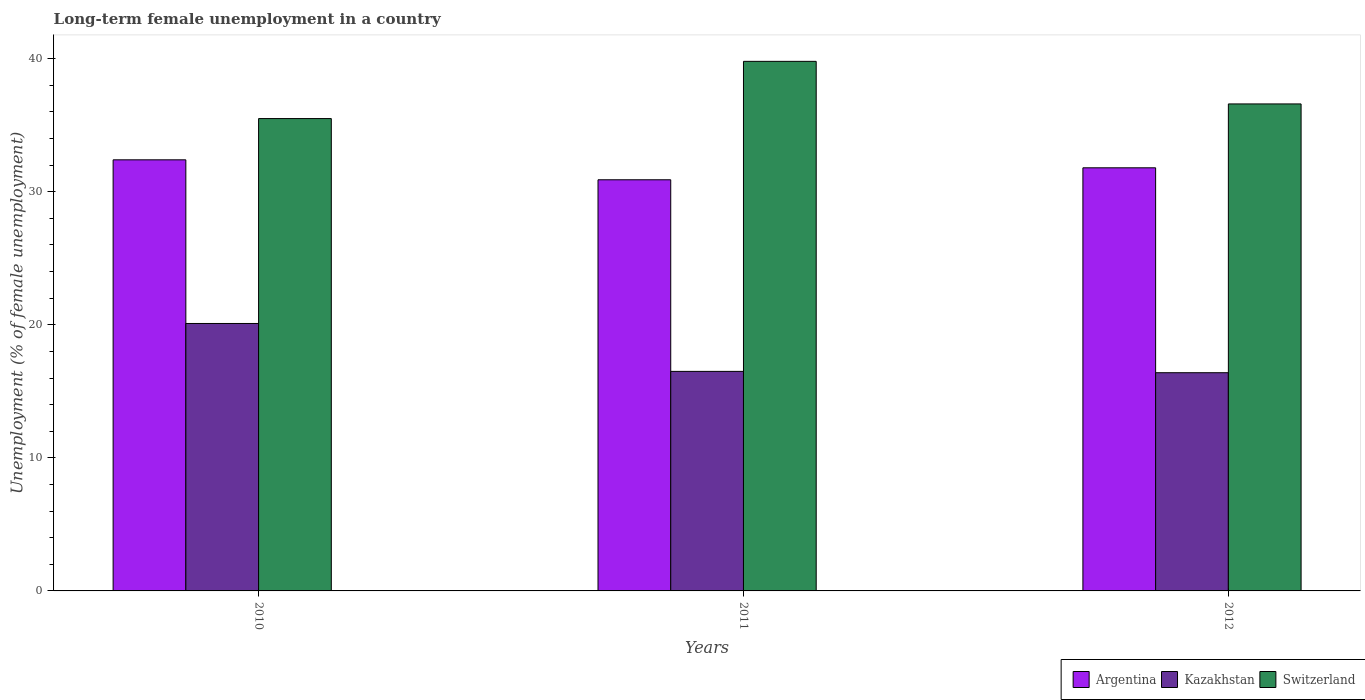Are the number of bars per tick equal to the number of legend labels?
Ensure brevity in your answer.  Yes. Are the number of bars on each tick of the X-axis equal?
Your answer should be very brief. Yes. How many bars are there on the 3rd tick from the right?
Provide a short and direct response. 3. What is the label of the 3rd group of bars from the left?
Your answer should be compact. 2012. What is the percentage of long-term unemployed female population in Argentina in 2012?
Your answer should be very brief. 31.8. Across all years, what is the maximum percentage of long-term unemployed female population in Argentina?
Keep it short and to the point. 32.4. Across all years, what is the minimum percentage of long-term unemployed female population in Kazakhstan?
Your response must be concise. 16.4. In which year was the percentage of long-term unemployed female population in Kazakhstan maximum?
Ensure brevity in your answer.  2010. In which year was the percentage of long-term unemployed female population in Kazakhstan minimum?
Your answer should be very brief. 2012. What is the total percentage of long-term unemployed female population in Switzerland in the graph?
Provide a succinct answer. 111.9. What is the difference between the percentage of long-term unemployed female population in Switzerland in 2011 and that in 2012?
Provide a short and direct response. 3.2. What is the difference between the percentage of long-term unemployed female population in Argentina in 2011 and the percentage of long-term unemployed female population in Switzerland in 2012?
Ensure brevity in your answer.  -5.7. What is the average percentage of long-term unemployed female population in Kazakhstan per year?
Offer a terse response. 17.67. In the year 2010, what is the difference between the percentage of long-term unemployed female population in Kazakhstan and percentage of long-term unemployed female population in Switzerland?
Offer a terse response. -15.4. What is the ratio of the percentage of long-term unemployed female population in Kazakhstan in 2010 to that in 2011?
Make the answer very short. 1.22. Is the percentage of long-term unemployed female population in Kazakhstan in 2010 less than that in 2012?
Provide a short and direct response. No. What is the difference between the highest and the second highest percentage of long-term unemployed female population in Kazakhstan?
Ensure brevity in your answer.  3.6. What is the difference between the highest and the lowest percentage of long-term unemployed female population in Kazakhstan?
Keep it short and to the point. 3.7. What does the 3rd bar from the left in 2012 represents?
Your answer should be very brief. Switzerland. What does the 2nd bar from the right in 2010 represents?
Ensure brevity in your answer.  Kazakhstan. What is the difference between two consecutive major ticks on the Y-axis?
Provide a short and direct response. 10. Are the values on the major ticks of Y-axis written in scientific E-notation?
Ensure brevity in your answer.  No. Does the graph contain any zero values?
Offer a very short reply. No. What is the title of the graph?
Provide a short and direct response. Long-term female unemployment in a country. Does "Kosovo" appear as one of the legend labels in the graph?
Provide a short and direct response. No. What is the label or title of the X-axis?
Offer a very short reply. Years. What is the label or title of the Y-axis?
Your answer should be compact. Unemployment (% of female unemployment). What is the Unemployment (% of female unemployment) in Argentina in 2010?
Your response must be concise. 32.4. What is the Unemployment (% of female unemployment) in Kazakhstan in 2010?
Offer a terse response. 20.1. What is the Unemployment (% of female unemployment) of Switzerland in 2010?
Give a very brief answer. 35.5. What is the Unemployment (% of female unemployment) in Argentina in 2011?
Ensure brevity in your answer.  30.9. What is the Unemployment (% of female unemployment) of Switzerland in 2011?
Offer a very short reply. 39.8. What is the Unemployment (% of female unemployment) in Argentina in 2012?
Provide a succinct answer. 31.8. What is the Unemployment (% of female unemployment) of Kazakhstan in 2012?
Offer a terse response. 16.4. What is the Unemployment (% of female unemployment) of Switzerland in 2012?
Your answer should be compact. 36.6. Across all years, what is the maximum Unemployment (% of female unemployment) of Argentina?
Make the answer very short. 32.4. Across all years, what is the maximum Unemployment (% of female unemployment) in Kazakhstan?
Ensure brevity in your answer.  20.1. Across all years, what is the maximum Unemployment (% of female unemployment) in Switzerland?
Make the answer very short. 39.8. Across all years, what is the minimum Unemployment (% of female unemployment) in Argentina?
Provide a short and direct response. 30.9. Across all years, what is the minimum Unemployment (% of female unemployment) of Kazakhstan?
Offer a terse response. 16.4. Across all years, what is the minimum Unemployment (% of female unemployment) in Switzerland?
Your response must be concise. 35.5. What is the total Unemployment (% of female unemployment) in Argentina in the graph?
Give a very brief answer. 95.1. What is the total Unemployment (% of female unemployment) in Kazakhstan in the graph?
Provide a short and direct response. 53. What is the total Unemployment (% of female unemployment) of Switzerland in the graph?
Provide a succinct answer. 111.9. What is the difference between the Unemployment (% of female unemployment) of Argentina in 2010 and that in 2011?
Give a very brief answer. 1.5. What is the difference between the Unemployment (% of female unemployment) in Kazakhstan in 2010 and that in 2011?
Your answer should be very brief. 3.6. What is the difference between the Unemployment (% of female unemployment) in Argentina in 2010 and that in 2012?
Provide a succinct answer. 0.6. What is the difference between the Unemployment (% of female unemployment) in Kazakhstan in 2010 and that in 2012?
Offer a very short reply. 3.7. What is the difference between the Unemployment (% of female unemployment) of Switzerland in 2010 and that in 2012?
Give a very brief answer. -1.1. What is the difference between the Unemployment (% of female unemployment) of Kazakhstan in 2011 and that in 2012?
Offer a very short reply. 0.1. What is the difference between the Unemployment (% of female unemployment) in Switzerland in 2011 and that in 2012?
Offer a very short reply. 3.2. What is the difference between the Unemployment (% of female unemployment) in Kazakhstan in 2010 and the Unemployment (% of female unemployment) in Switzerland in 2011?
Offer a very short reply. -19.7. What is the difference between the Unemployment (% of female unemployment) of Argentina in 2010 and the Unemployment (% of female unemployment) of Switzerland in 2012?
Your answer should be compact. -4.2. What is the difference between the Unemployment (% of female unemployment) in Kazakhstan in 2010 and the Unemployment (% of female unemployment) in Switzerland in 2012?
Your response must be concise. -16.5. What is the difference between the Unemployment (% of female unemployment) of Kazakhstan in 2011 and the Unemployment (% of female unemployment) of Switzerland in 2012?
Your answer should be compact. -20.1. What is the average Unemployment (% of female unemployment) of Argentina per year?
Your answer should be very brief. 31.7. What is the average Unemployment (% of female unemployment) of Kazakhstan per year?
Give a very brief answer. 17.67. What is the average Unemployment (% of female unemployment) of Switzerland per year?
Make the answer very short. 37.3. In the year 2010, what is the difference between the Unemployment (% of female unemployment) of Argentina and Unemployment (% of female unemployment) of Kazakhstan?
Give a very brief answer. 12.3. In the year 2010, what is the difference between the Unemployment (% of female unemployment) of Kazakhstan and Unemployment (% of female unemployment) of Switzerland?
Provide a short and direct response. -15.4. In the year 2011, what is the difference between the Unemployment (% of female unemployment) in Argentina and Unemployment (% of female unemployment) in Switzerland?
Provide a short and direct response. -8.9. In the year 2011, what is the difference between the Unemployment (% of female unemployment) in Kazakhstan and Unemployment (% of female unemployment) in Switzerland?
Offer a very short reply. -23.3. In the year 2012, what is the difference between the Unemployment (% of female unemployment) of Kazakhstan and Unemployment (% of female unemployment) of Switzerland?
Keep it short and to the point. -20.2. What is the ratio of the Unemployment (% of female unemployment) in Argentina in 2010 to that in 2011?
Your answer should be compact. 1.05. What is the ratio of the Unemployment (% of female unemployment) in Kazakhstan in 2010 to that in 2011?
Give a very brief answer. 1.22. What is the ratio of the Unemployment (% of female unemployment) in Switzerland in 2010 to that in 2011?
Your answer should be compact. 0.89. What is the ratio of the Unemployment (% of female unemployment) in Argentina in 2010 to that in 2012?
Provide a succinct answer. 1.02. What is the ratio of the Unemployment (% of female unemployment) in Kazakhstan in 2010 to that in 2012?
Ensure brevity in your answer.  1.23. What is the ratio of the Unemployment (% of female unemployment) of Switzerland in 2010 to that in 2012?
Provide a short and direct response. 0.97. What is the ratio of the Unemployment (% of female unemployment) of Argentina in 2011 to that in 2012?
Offer a terse response. 0.97. What is the ratio of the Unemployment (% of female unemployment) of Kazakhstan in 2011 to that in 2012?
Provide a short and direct response. 1.01. What is the ratio of the Unemployment (% of female unemployment) of Switzerland in 2011 to that in 2012?
Your answer should be compact. 1.09. What is the difference between the highest and the lowest Unemployment (% of female unemployment) of Argentina?
Your answer should be very brief. 1.5. 